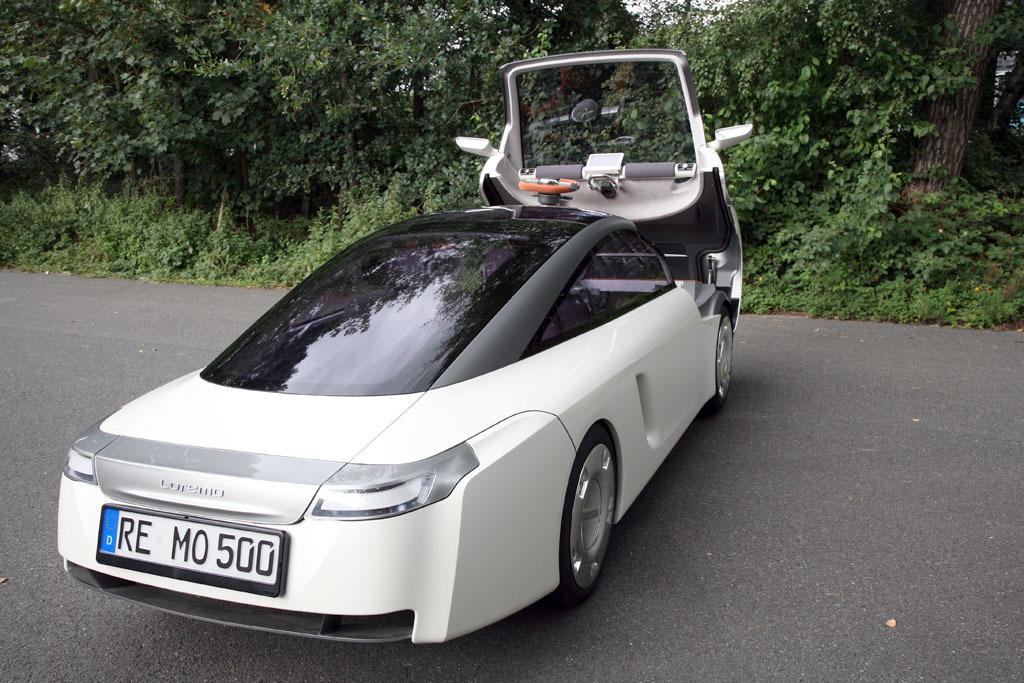How would you summarize this image in a sentence or two? In this image I can see a vehicle in white color and the vehicle is on the road. Background I can see trees in green color and sky is in white color. 